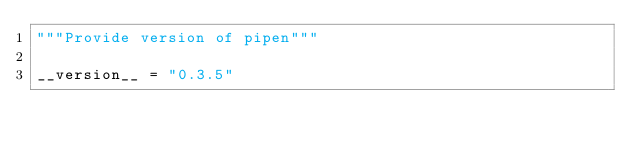<code> <loc_0><loc_0><loc_500><loc_500><_Python_>"""Provide version of pipen"""

__version__ = "0.3.5"
</code> 